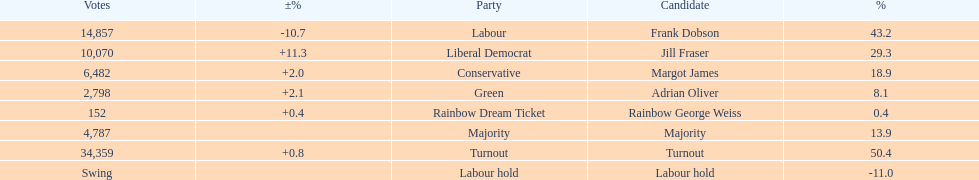How many votes did both the conservative party and the rainbow dream ticket party receive? 6634. 